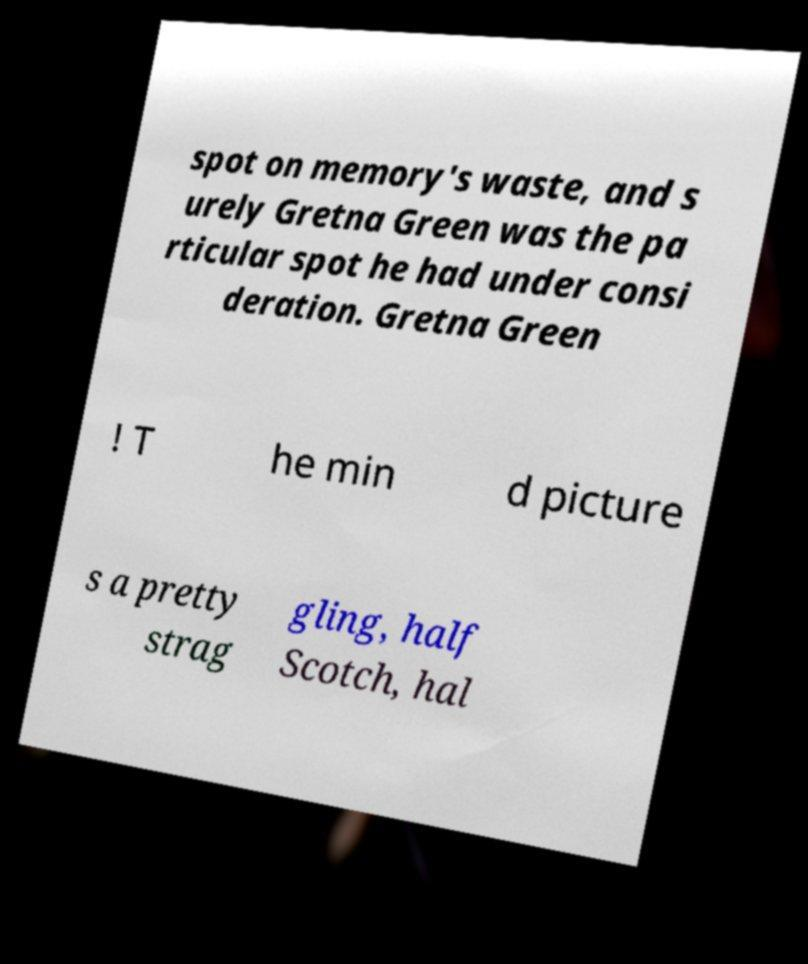I need the written content from this picture converted into text. Can you do that? spot on memory's waste, and s urely Gretna Green was the pa rticular spot he had under consi deration. Gretna Green ! T he min d picture s a pretty strag gling, half Scotch, hal 